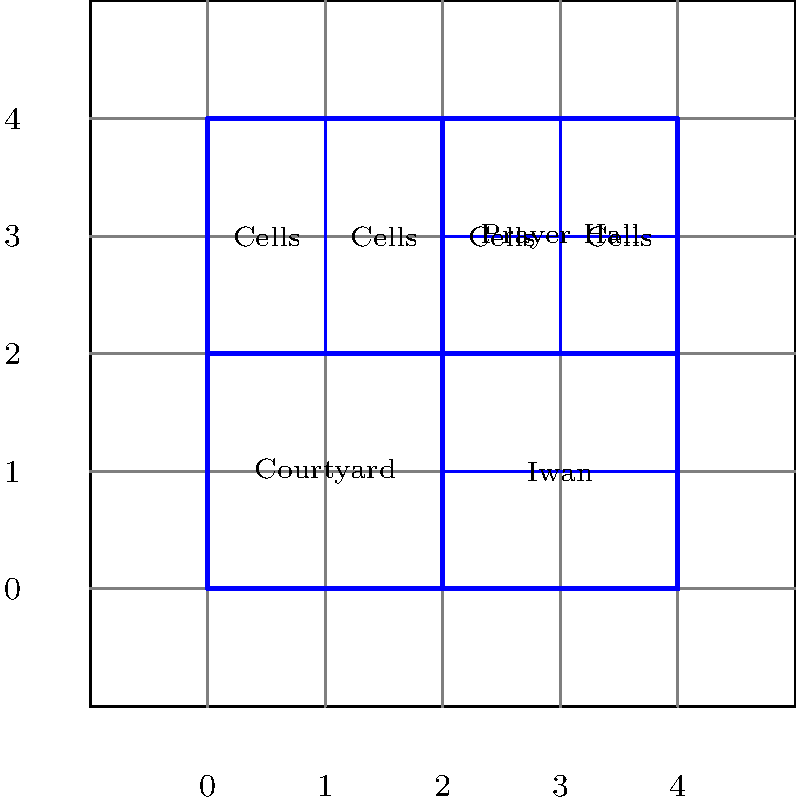In the 2D floor plan of a Timurid-era madrasa shown above, what are the coordinates of the bottom-right corner of the prayer hall? To determine the coordinates of the bottom-right corner of the prayer hall, we need to follow these steps:

1. Identify the prayer hall on the floor plan. It is labeled in the upper-right quadrant of the madrasa layout.

2. Locate the bottom-right corner of the prayer hall. This corner is where the prayer hall meets the iwan and is part of the central vertical line dividing the madrasa.

3. Determine the x-coordinate:
   - The madrasa layout is divided into 4 equal parts horizontally.
   - The prayer hall occupies the right half of the upper section.
   - The bottom-right corner aligns with the central vertical line.
   - This corresponds to an x-coordinate of 2.

4. Determine the y-coordinate:
   - The madrasa layout is divided into 4 equal parts vertically.
   - The prayer hall is in the upper half of the layout.
   - Its bottom edge aligns with the central horizontal line.
   - This corresponds to a y-coordinate of 2.

5. Combine the x and y coordinates to get the final answer: (2, 2).

This point (2, 2) represents the intersection of the central vertical and horizontal lines of the madrasa layout, which is precisely where the bottom-right corner of the prayer hall is located.
Answer: (2, 2) 